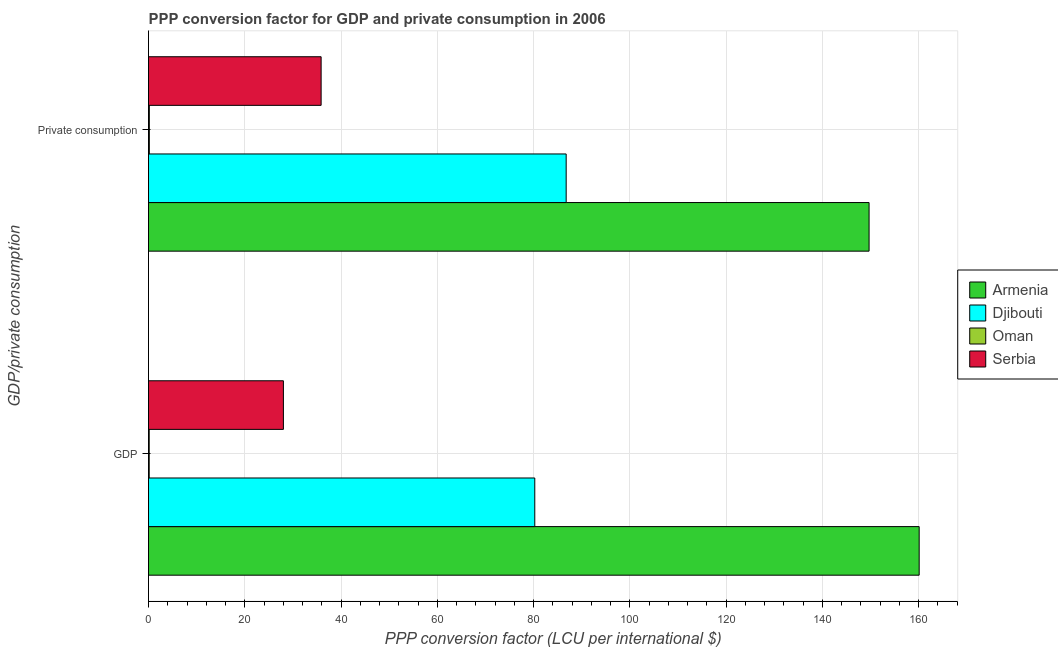How many groups of bars are there?
Provide a succinct answer. 2. Are the number of bars per tick equal to the number of legend labels?
Your response must be concise. Yes. Are the number of bars on each tick of the Y-axis equal?
Offer a terse response. Yes. What is the label of the 2nd group of bars from the top?
Provide a succinct answer. GDP. What is the ppp conversion factor for gdp in Serbia?
Provide a succinct answer. 28.02. Across all countries, what is the maximum ppp conversion factor for gdp?
Your answer should be compact. 160.11. Across all countries, what is the minimum ppp conversion factor for private consumption?
Provide a short and direct response. 0.17. In which country was the ppp conversion factor for private consumption maximum?
Ensure brevity in your answer.  Armenia. In which country was the ppp conversion factor for private consumption minimum?
Provide a succinct answer. Oman. What is the total ppp conversion factor for gdp in the graph?
Your answer should be very brief. 268.52. What is the difference between the ppp conversion factor for private consumption in Armenia and that in Serbia?
Make the answer very short. 113.84. What is the difference between the ppp conversion factor for private consumption in Djibouti and the ppp conversion factor for gdp in Oman?
Make the answer very short. 86.62. What is the average ppp conversion factor for private consumption per country?
Offer a terse response. 68.12. What is the difference between the ppp conversion factor for gdp and ppp conversion factor for private consumption in Oman?
Ensure brevity in your answer.  -0.03. In how many countries, is the ppp conversion factor for private consumption greater than 136 LCU?
Your response must be concise. 1. What is the ratio of the ppp conversion factor for private consumption in Djibouti to that in Armenia?
Offer a very short reply. 0.58. Is the ppp conversion factor for gdp in Djibouti less than that in Serbia?
Keep it short and to the point. No. In how many countries, is the ppp conversion factor for gdp greater than the average ppp conversion factor for gdp taken over all countries?
Your answer should be compact. 2. What does the 3rd bar from the top in  Private consumption represents?
Offer a terse response. Djibouti. What does the 3rd bar from the bottom in GDP represents?
Offer a very short reply. Oman. How many bars are there?
Provide a succinct answer. 8. Are all the bars in the graph horizontal?
Keep it short and to the point. Yes. How many countries are there in the graph?
Offer a very short reply. 4. Are the values on the major ticks of X-axis written in scientific E-notation?
Provide a short and direct response. No. Does the graph contain any zero values?
Your answer should be compact. No. Does the graph contain grids?
Offer a very short reply. Yes. How many legend labels are there?
Offer a terse response. 4. What is the title of the graph?
Your answer should be compact. PPP conversion factor for GDP and private consumption in 2006. Does "Madagascar" appear as one of the legend labels in the graph?
Provide a succinct answer. No. What is the label or title of the X-axis?
Your response must be concise. PPP conversion factor (LCU per international $). What is the label or title of the Y-axis?
Offer a terse response. GDP/private consumption. What is the PPP conversion factor (LCU per international $) of Armenia in GDP?
Make the answer very short. 160.11. What is the PPP conversion factor (LCU per international $) of Djibouti in GDP?
Your response must be concise. 80.25. What is the PPP conversion factor (LCU per international $) in Oman in GDP?
Your response must be concise. 0.14. What is the PPP conversion factor (LCU per international $) in Serbia in GDP?
Give a very brief answer. 28.02. What is the PPP conversion factor (LCU per international $) in Armenia in  Private consumption?
Your response must be concise. 149.7. What is the PPP conversion factor (LCU per international $) in Djibouti in  Private consumption?
Your answer should be very brief. 86.77. What is the PPP conversion factor (LCU per international $) in Oman in  Private consumption?
Keep it short and to the point. 0.17. What is the PPP conversion factor (LCU per international $) in Serbia in  Private consumption?
Offer a terse response. 35.86. Across all GDP/private consumption, what is the maximum PPP conversion factor (LCU per international $) in Armenia?
Provide a short and direct response. 160.11. Across all GDP/private consumption, what is the maximum PPP conversion factor (LCU per international $) of Djibouti?
Keep it short and to the point. 86.77. Across all GDP/private consumption, what is the maximum PPP conversion factor (LCU per international $) in Oman?
Provide a short and direct response. 0.17. Across all GDP/private consumption, what is the maximum PPP conversion factor (LCU per international $) in Serbia?
Your answer should be compact. 35.86. Across all GDP/private consumption, what is the minimum PPP conversion factor (LCU per international $) of Armenia?
Provide a short and direct response. 149.7. Across all GDP/private consumption, what is the minimum PPP conversion factor (LCU per international $) of Djibouti?
Offer a very short reply. 80.25. Across all GDP/private consumption, what is the minimum PPP conversion factor (LCU per international $) of Oman?
Give a very brief answer. 0.14. Across all GDP/private consumption, what is the minimum PPP conversion factor (LCU per international $) in Serbia?
Provide a succinct answer. 28.02. What is the total PPP conversion factor (LCU per international $) of Armenia in the graph?
Make the answer very short. 309.8. What is the total PPP conversion factor (LCU per international $) of Djibouti in the graph?
Make the answer very short. 167.01. What is the total PPP conversion factor (LCU per international $) of Oman in the graph?
Offer a very short reply. 0.31. What is the total PPP conversion factor (LCU per international $) in Serbia in the graph?
Your answer should be very brief. 63.88. What is the difference between the PPP conversion factor (LCU per international $) of Armenia in GDP and that in  Private consumption?
Your response must be concise. 10.41. What is the difference between the PPP conversion factor (LCU per international $) of Djibouti in GDP and that in  Private consumption?
Provide a succinct answer. -6.52. What is the difference between the PPP conversion factor (LCU per international $) in Oman in GDP and that in  Private consumption?
Provide a succinct answer. -0.03. What is the difference between the PPP conversion factor (LCU per international $) in Serbia in GDP and that in  Private consumption?
Ensure brevity in your answer.  -7.84. What is the difference between the PPP conversion factor (LCU per international $) of Armenia in GDP and the PPP conversion factor (LCU per international $) of Djibouti in  Private consumption?
Ensure brevity in your answer.  73.34. What is the difference between the PPP conversion factor (LCU per international $) of Armenia in GDP and the PPP conversion factor (LCU per international $) of Oman in  Private consumption?
Provide a short and direct response. 159.94. What is the difference between the PPP conversion factor (LCU per international $) of Armenia in GDP and the PPP conversion factor (LCU per international $) of Serbia in  Private consumption?
Your answer should be compact. 124.25. What is the difference between the PPP conversion factor (LCU per international $) in Djibouti in GDP and the PPP conversion factor (LCU per international $) in Oman in  Private consumption?
Make the answer very short. 80.08. What is the difference between the PPP conversion factor (LCU per international $) of Djibouti in GDP and the PPP conversion factor (LCU per international $) of Serbia in  Private consumption?
Keep it short and to the point. 44.39. What is the difference between the PPP conversion factor (LCU per international $) of Oman in GDP and the PPP conversion factor (LCU per international $) of Serbia in  Private consumption?
Provide a short and direct response. -35.72. What is the average PPP conversion factor (LCU per international $) of Armenia per GDP/private consumption?
Offer a terse response. 154.9. What is the average PPP conversion factor (LCU per international $) of Djibouti per GDP/private consumption?
Give a very brief answer. 83.51. What is the average PPP conversion factor (LCU per international $) of Oman per GDP/private consumption?
Offer a terse response. 0.16. What is the average PPP conversion factor (LCU per international $) of Serbia per GDP/private consumption?
Your response must be concise. 31.94. What is the difference between the PPP conversion factor (LCU per international $) of Armenia and PPP conversion factor (LCU per international $) of Djibouti in GDP?
Provide a succinct answer. 79.86. What is the difference between the PPP conversion factor (LCU per international $) in Armenia and PPP conversion factor (LCU per international $) in Oman in GDP?
Offer a very short reply. 159.96. What is the difference between the PPP conversion factor (LCU per international $) in Armenia and PPP conversion factor (LCU per international $) in Serbia in GDP?
Provide a short and direct response. 132.08. What is the difference between the PPP conversion factor (LCU per international $) of Djibouti and PPP conversion factor (LCU per international $) of Oman in GDP?
Give a very brief answer. 80.11. What is the difference between the PPP conversion factor (LCU per international $) in Djibouti and PPP conversion factor (LCU per international $) in Serbia in GDP?
Your answer should be very brief. 52.23. What is the difference between the PPP conversion factor (LCU per international $) in Oman and PPP conversion factor (LCU per international $) in Serbia in GDP?
Make the answer very short. -27.88. What is the difference between the PPP conversion factor (LCU per international $) of Armenia and PPP conversion factor (LCU per international $) of Djibouti in  Private consumption?
Provide a succinct answer. 62.93. What is the difference between the PPP conversion factor (LCU per international $) of Armenia and PPP conversion factor (LCU per international $) of Oman in  Private consumption?
Provide a short and direct response. 149.53. What is the difference between the PPP conversion factor (LCU per international $) in Armenia and PPP conversion factor (LCU per international $) in Serbia in  Private consumption?
Ensure brevity in your answer.  113.84. What is the difference between the PPP conversion factor (LCU per international $) in Djibouti and PPP conversion factor (LCU per international $) in Oman in  Private consumption?
Offer a terse response. 86.6. What is the difference between the PPP conversion factor (LCU per international $) of Djibouti and PPP conversion factor (LCU per international $) of Serbia in  Private consumption?
Give a very brief answer. 50.91. What is the difference between the PPP conversion factor (LCU per international $) of Oman and PPP conversion factor (LCU per international $) of Serbia in  Private consumption?
Offer a very short reply. -35.69. What is the ratio of the PPP conversion factor (LCU per international $) of Armenia in GDP to that in  Private consumption?
Keep it short and to the point. 1.07. What is the ratio of the PPP conversion factor (LCU per international $) of Djibouti in GDP to that in  Private consumption?
Your answer should be compact. 0.92. What is the ratio of the PPP conversion factor (LCU per international $) in Oman in GDP to that in  Private consumption?
Offer a terse response. 0.84. What is the ratio of the PPP conversion factor (LCU per international $) of Serbia in GDP to that in  Private consumption?
Your response must be concise. 0.78. What is the difference between the highest and the second highest PPP conversion factor (LCU per international $) in Armenia?
Offer a terse response. 10.41. What is the difference between the highest and the second highest PPP conversion factor (LCU per international $) of Djibouti?
Make the answer very short. 6.52. What is the difference between the highest and the second highest PPP conversion factor (LCU per international $) of Oman?
Offer a very short reply. 0.03. What is the difference between the highest and the second highest PPP conversion factor (LCU per international $) of Serbia?
Ensure brevity in your answer.  7.84. What is the difference between the highest and the lowest PPP conversion factor (LCU per international $) in Armenia?
Provide a succinct answer. 10.41. What is the difference between the highest and the lowest PPP conversion factor (LCU per international $) of Djibouti?
Your response must be concise. 6.52. What is the difference between the highest and the lowest PPP conversion factor (LCU per international $) of Oman?
Provide a succinct answer. 0.03. What is the difference between the highest and the lowest PPP conversion factor (LCU per international $) in Serbia?
Keep it short and to the point. 7.84. 